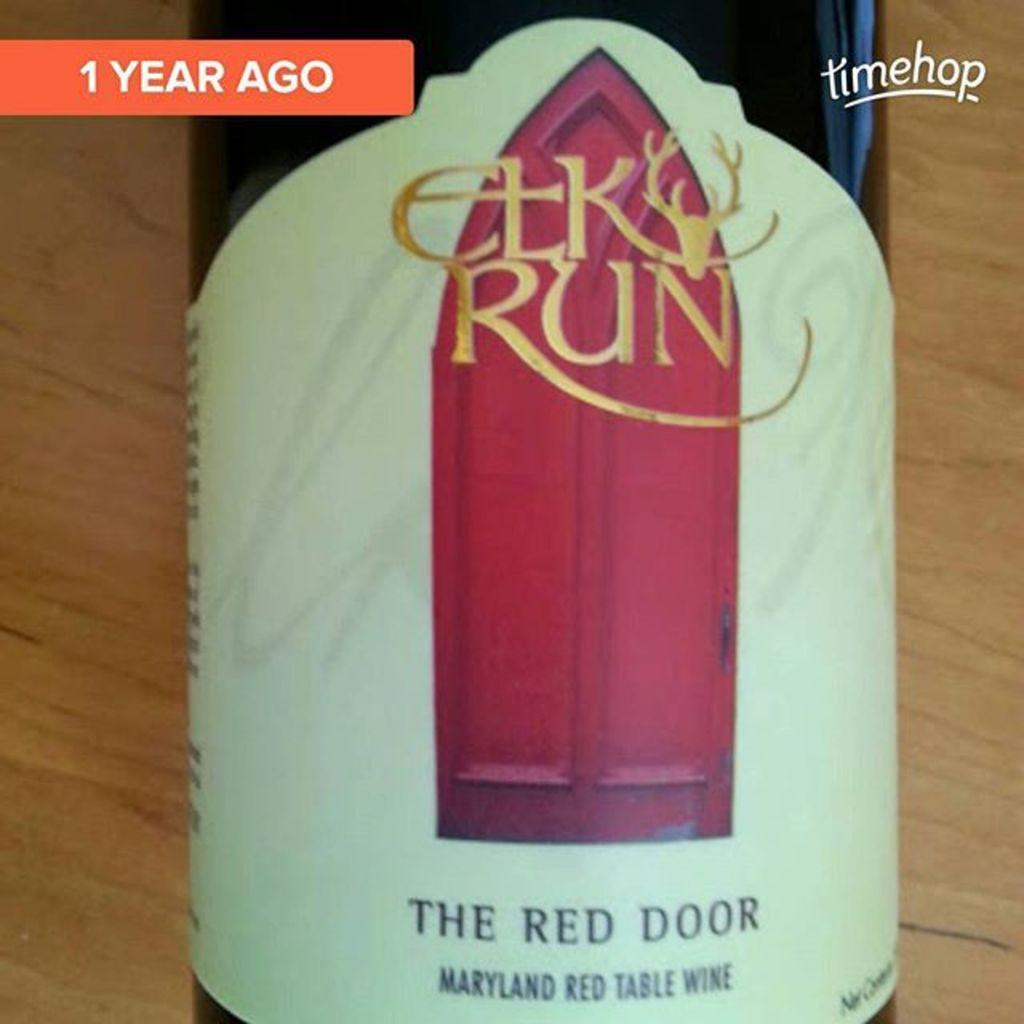<image>
Offer a succinct explanation of the picture presented. The Red Door bottle of wine from Maryland 